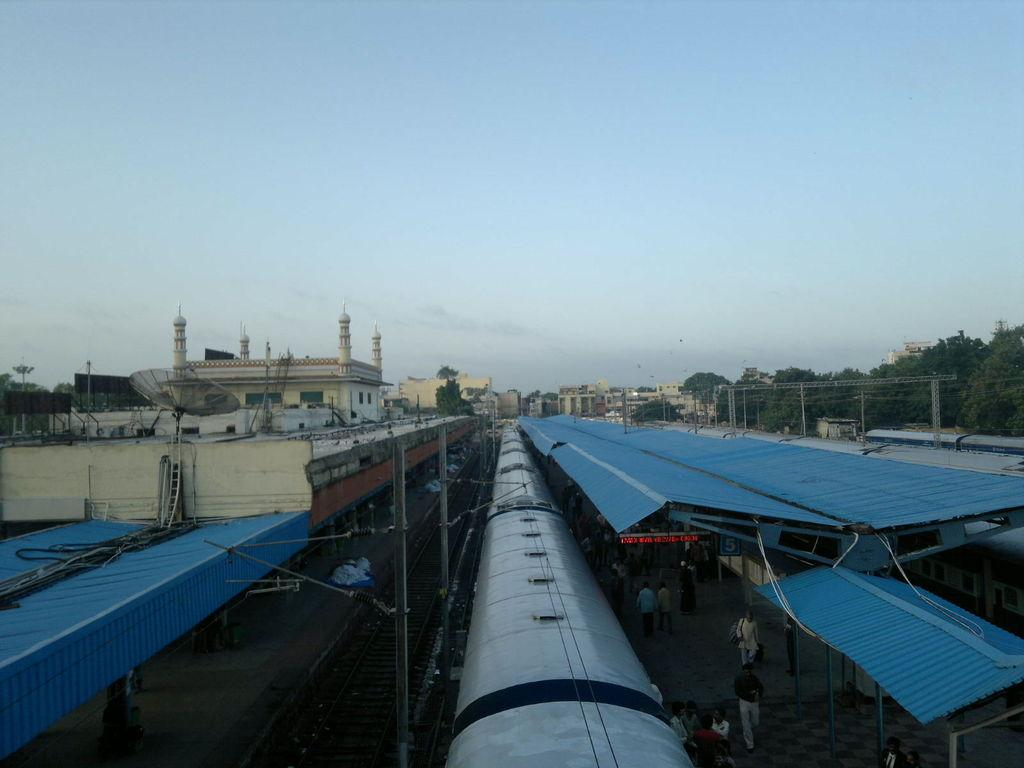What type of vehicles are in the image? There are trains in the image. What structures are located beside the trains? There are platforms beside the trains. Can you describe the people in the image? There are people in the image. What is the main feature of the transportation system depicted in the image? A railway track is visible in the image. What can be seen in the background of the image? There are buildings, trees, poles, and the sky visible in the background of the image. What type of seashore can be seen in the image? There is no seashore present in the image; it features trains, platforms, and a railway track. What form of industry is depicted in the image? The image does not depict a specific industry; it shows a transportation system with trains and platforms. 